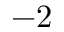Convert formula to latex. <formula><loc_0><loc_0><loc_500><loc_500>- 2</formula> 